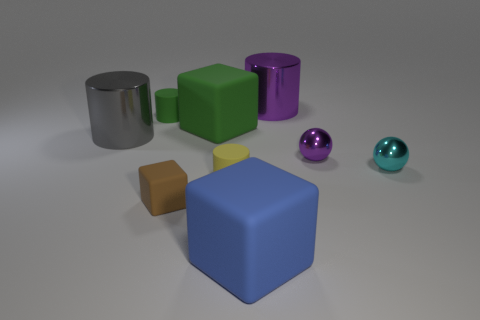The gray thing that is the same size as the purple shiny cylinder is what shape?
Your answer should be very brief. Cylinder. Is there a gray metallic thing of the same shape as the big blue rubber thing?
Make the answer very short. No. Is the shape of the large metallic object on the left side of the yellow rubber thing the same as the tiny yellow matte object in front of the purple cylinder?
Provide a short and direct response. Yes. There is a cyan sphere that is the same size as the yellow rubber cylinder; what material is it?
Your answer should be compact. Metal. What number of other things are the same material as the small purple thing?
Offer a very short reply. 3. What is the shape of the rubber thing that is behind the large matte block behind the big blue cube?
Give a very brief answer. Cylinder. How many things are big rubber blocks or rubber things behind the large blue matte cube?
Ensure brevity in your answer.  5. How many other objects are there of the same color as the small rubber cube?
Your answer should be very brief. 0. How many green objects are either large metal cylinders or tiny shiny balls?
Your answer should be compact. 0. There is a metal cylinder left of the small object that is behind the gray metal cylinder; are there any tiny yellow objects on the left side of it?
Give a very brief answer. No. 